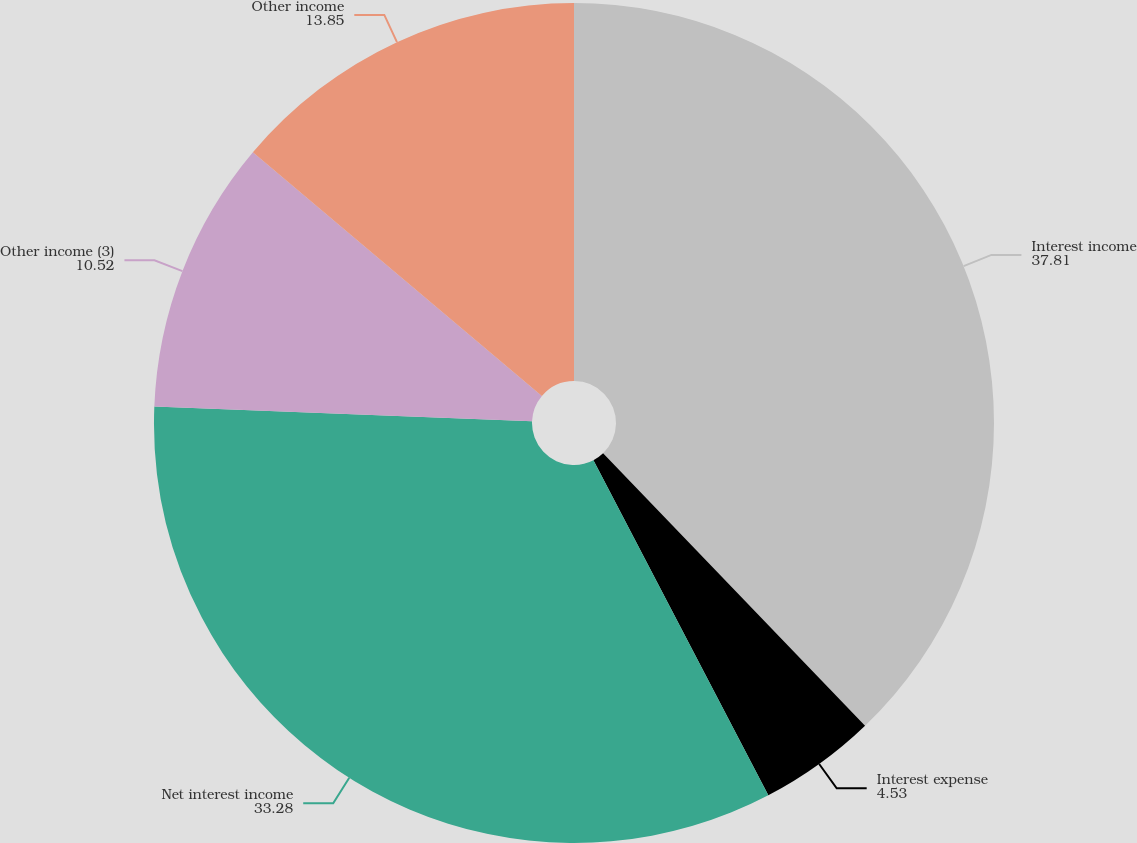<chart> <loc_0><loc_0><loc_500><loc_500><pie_chart><fcel>Interest income<fcel>Interest expense<fcel>Net interest income<fcel>Other income (3)<fcel>Other income<nl><fcel>37.81%<fcel>4.53%<fcel>33.28%<fcel>10.52%<fcel>13.85%<nl></chart> 